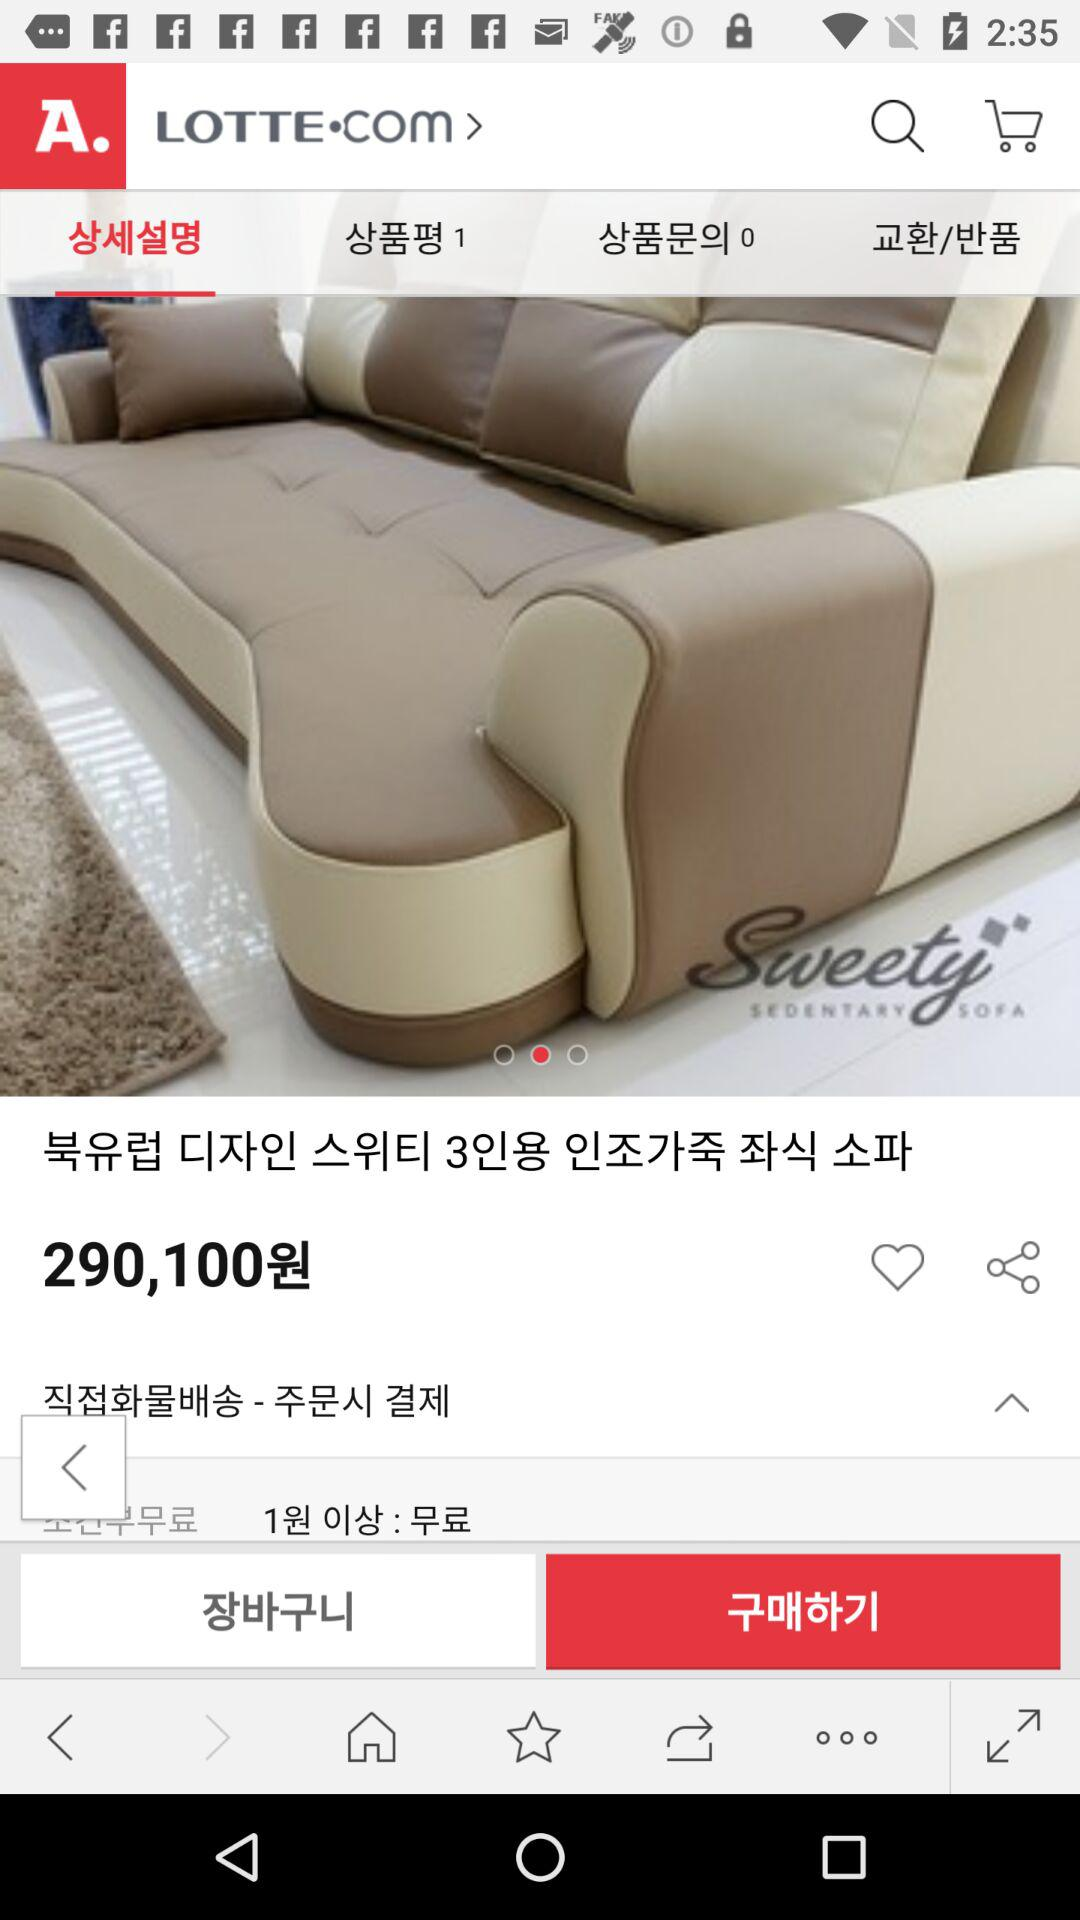How much do I have to pay if I order this product?
Answer the question using a single word or phrase. 290,100원 